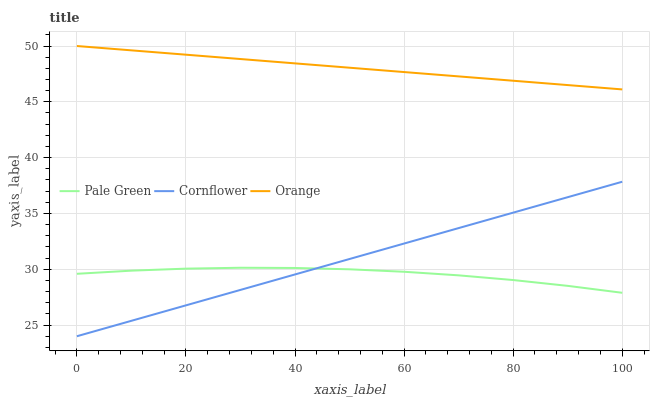Does Pale Green have the minimum area under the curve?
Answer yes or no. Yes. Does Orange have the maximum area under the curve?
Answer yes or no. Yes. Does Cornflower have the minimum area under the curve?
Answer yes or no. No. Does Cornflower have the maximum area under the curve?
Answer yes or no. No. Is Cornflower the smoothest?
Answer yes or no. Yes. Is Pale Green the roughest?
Answer yes or no. Yes. Is Pale Green the smoothest?
Answer yes or no. No. Is Cornflower the roughest?
Answer yes or no. No. Does Cornflower have the lowest value?
Answer yes or no. Yes. Does Pale Green have the lowest value?
Answer yes or no. No. Does Orange have the highest value?
Answer yes or no. Yes. Does Cornflower have the highest value?
Answer yes or no. No. Is Cornflower less than Orange?
Answer yes or no. Yes. Is Orange greater than Cornflower?
Answer yes or no. Yes. Does Cornflower intersect Pale Green?
Answer yes or no. Yes. Is Cornflower less than Pale Green?
Answer yes or no. No. Is Cornflower greater than Pale Green?
Answer yes or no. No. Does Cornflower intersect Orange?
Answer yes or no. No. 